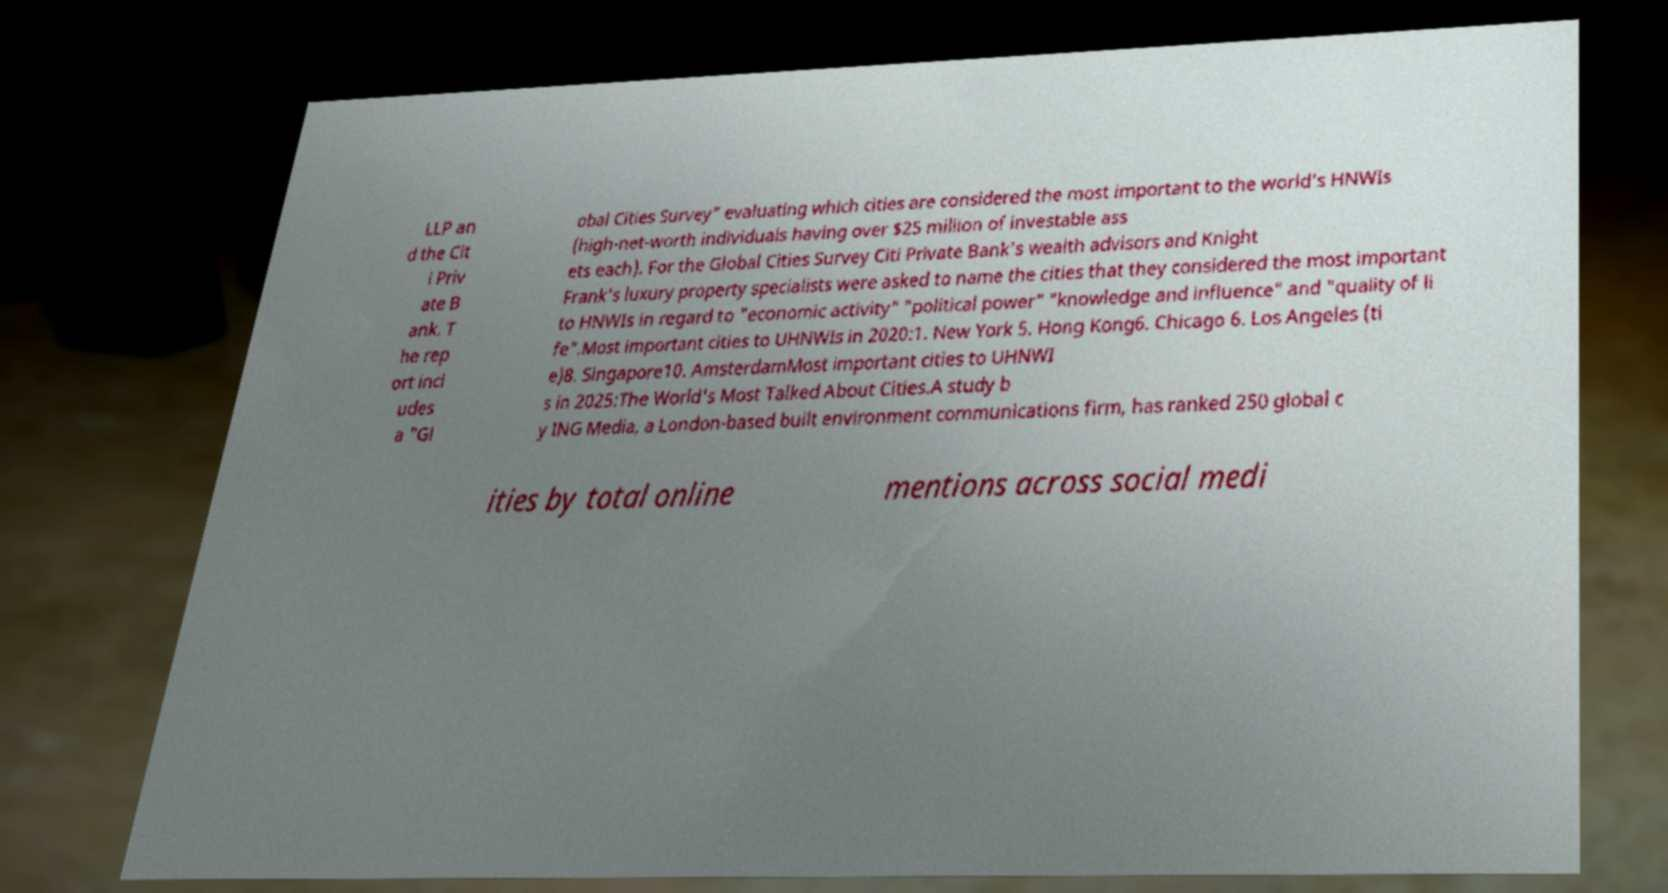For documentation purposes, I need the text within this image transcribed. Could you provide that? LLP an d the Cit i Priv ate B ank. T he rep ort incl udes a "Gl obal Cities Survey" evaluating which cities are considered the most important to the world's HNWIs (high-net-worth individuals having over $25 million of investable ass ets each). For the Global Cities Survey Citi Private Bank's wealth advisors and Knight Frank's luxury property specialists were asked to name the cities that they considered the most important to HNWIs in regard to "economic activity" "political power" "knowledge and influence" and "quality of li fe".Most important cities to UHNWIs in 2020:1. New York 5. Hong Kong6. Chicago 6. Los Angeles (ti e)8. Singapore10. AmsterdamMost important cities to UHNWI s in 2025:The World's Most Talked About Cities.A study b y ING Media, a London-based built environment communications firm, has ranked 250 global c ities by total online mentions across social medi 